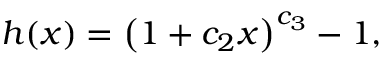Convert formula to latex. <formula><loc_0><loc_0><loc_500><loc_500>h ( x ) = \left ( 1 + c _ { 2 } x \right ) ^ { c _ { 3 } } - 1 ,</formula> 